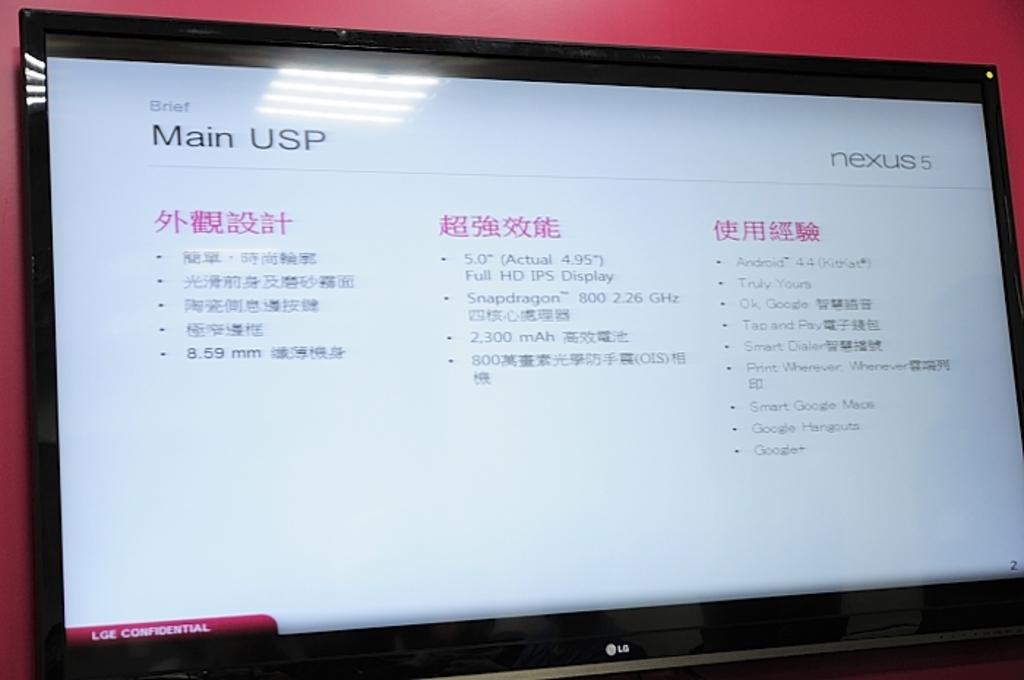What phone model on the top right is featured?
Provide a short and direct response. Nexus 5. What version of android does this phone use?
Keep it short and to the point. 4.4. 